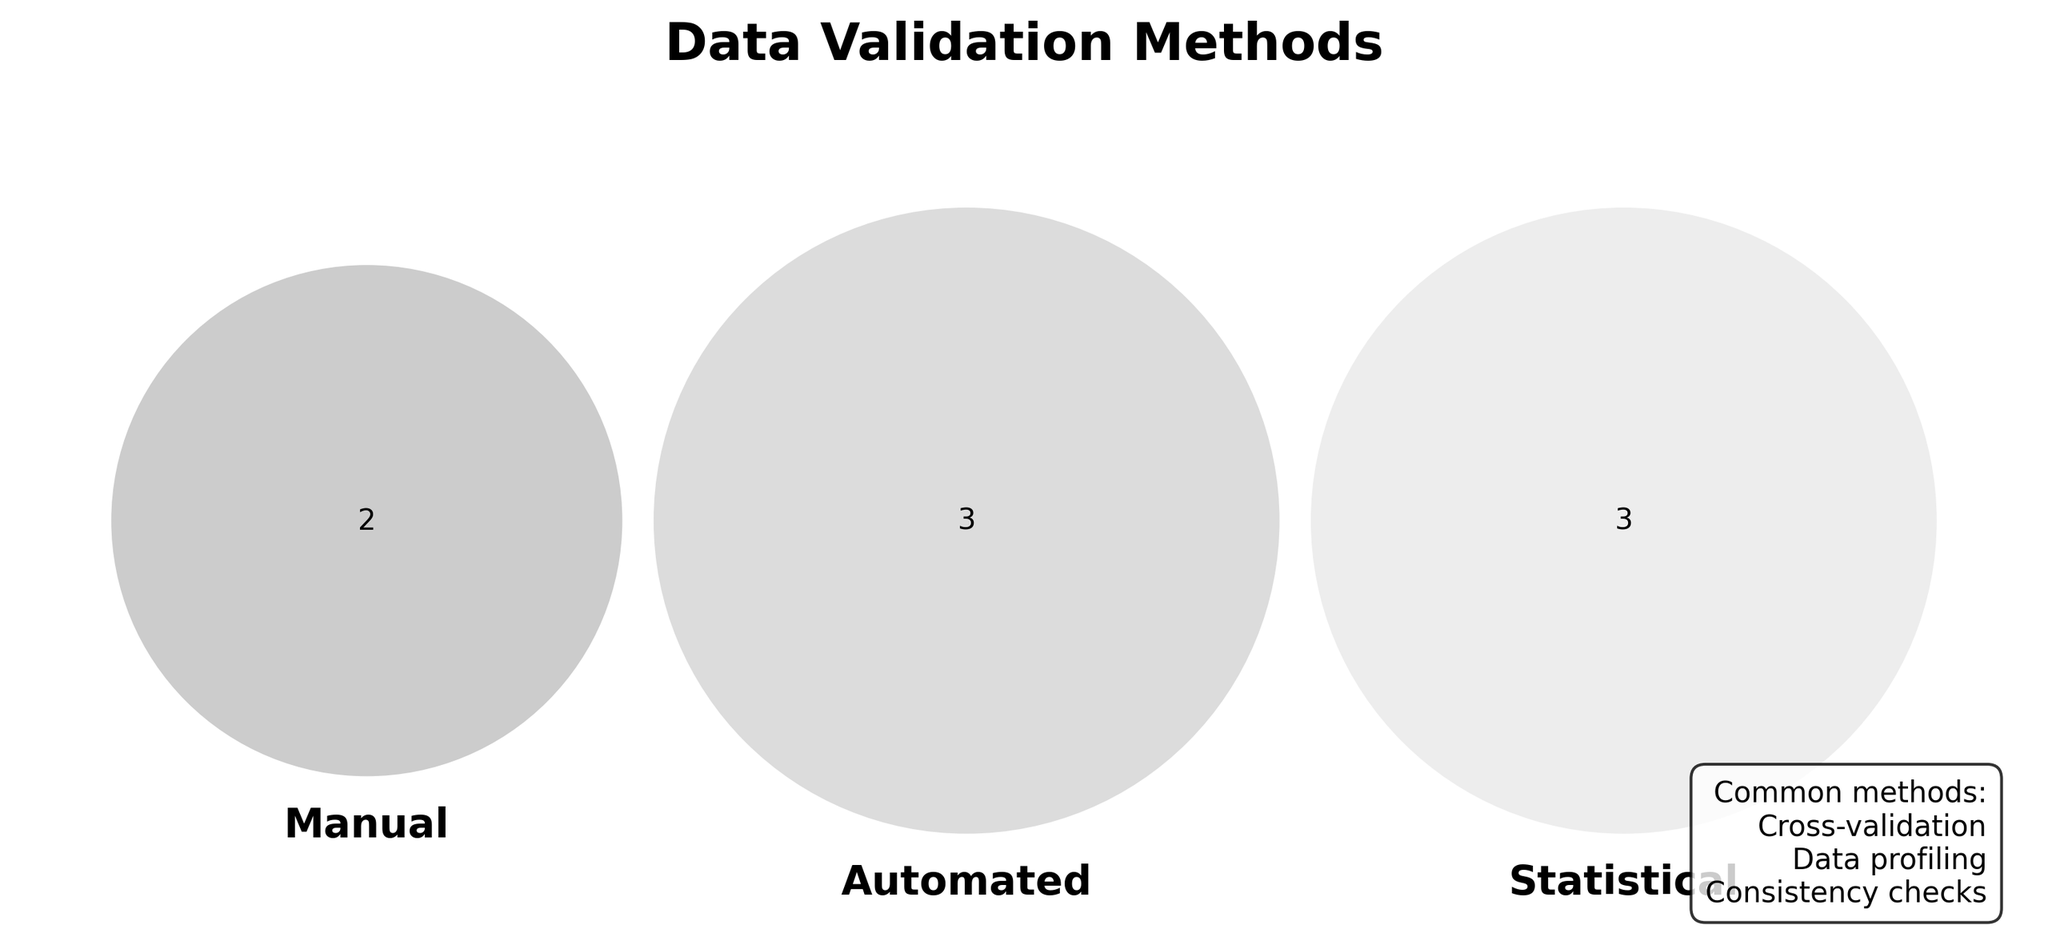what are the main categories represented in the Venn diagram? The main categories are the labels associated with each set in the Venn diagram. The labels are 'Manual', 'Automated', and 'Statistical'.
Answer: Manual, Automated, Statistical What is the title of the Venn diagram? The title is usually displayed at the top of the figure. It reads 'Data Validation Methods'.
Answer: Data Validation Methods Which category has the method 'Visual inspection'? To determine this, look for 'Visual inspection' in the label of the set. It is part of the 'Manual' category.
Answer: Manual List all methods common to all categories. The common methods are usually noted in the figure. They include 'Cross-validation', 'Data profiling', and 'Consistency checks'.
Answer: Cross-validation, Data profiling, Consistency checks Which 'Automated' method detects values that fall outside an expected range? Look into the set labeled 'Automated' for methods that perform such functions. 'Range checks' is the one that fits this criterion.
Answer: Range checks Are there any methods that are only found in the 'Statistical' category? Check the 'Statistical' set for methods that do not overlap with either 'Manual' or 'Automated' categories. 'Correlation analysis', 'Distribution analysis', and 'Hypothesis testing' are exclusive to this category.
Answer: Yes How many methods are unique to the 'Manual' category? Identify the methods in the 'Manual' set that do not overlap with the other categories. There are two such methods: 'Visual inspection' and 'Domain expert review'.
Answer: 2 Which category interacts with 'Outlier detection'? Check the Venn section where the 'Outlier detection' method is located. It falls under the 'Automated' category.
Answer: Automated Is 'Format validation' common between 'Manual' and 'Automated' categories? Look at the intersection between 'Manual' and 'Automated' sets. 'Format validation' appears only in 'Automated', not in both.
Answer: No Which manual method relies on domain knowledge? Look into the 'Manual' set for a method requiring domain-specific expertise. 'Domain expert review' fits this description.
Answer: Domain expert review 